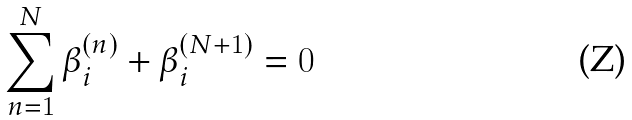Convert formula to latex. <formula><loc_0><loc_0><loc_500><loc_500>\sum _ { n = 1 } ^ { N } \beta _ { i } ^ { ( n ) } + \beta _ { i } ^ { ( N + 1 ) } = 0</formula> 